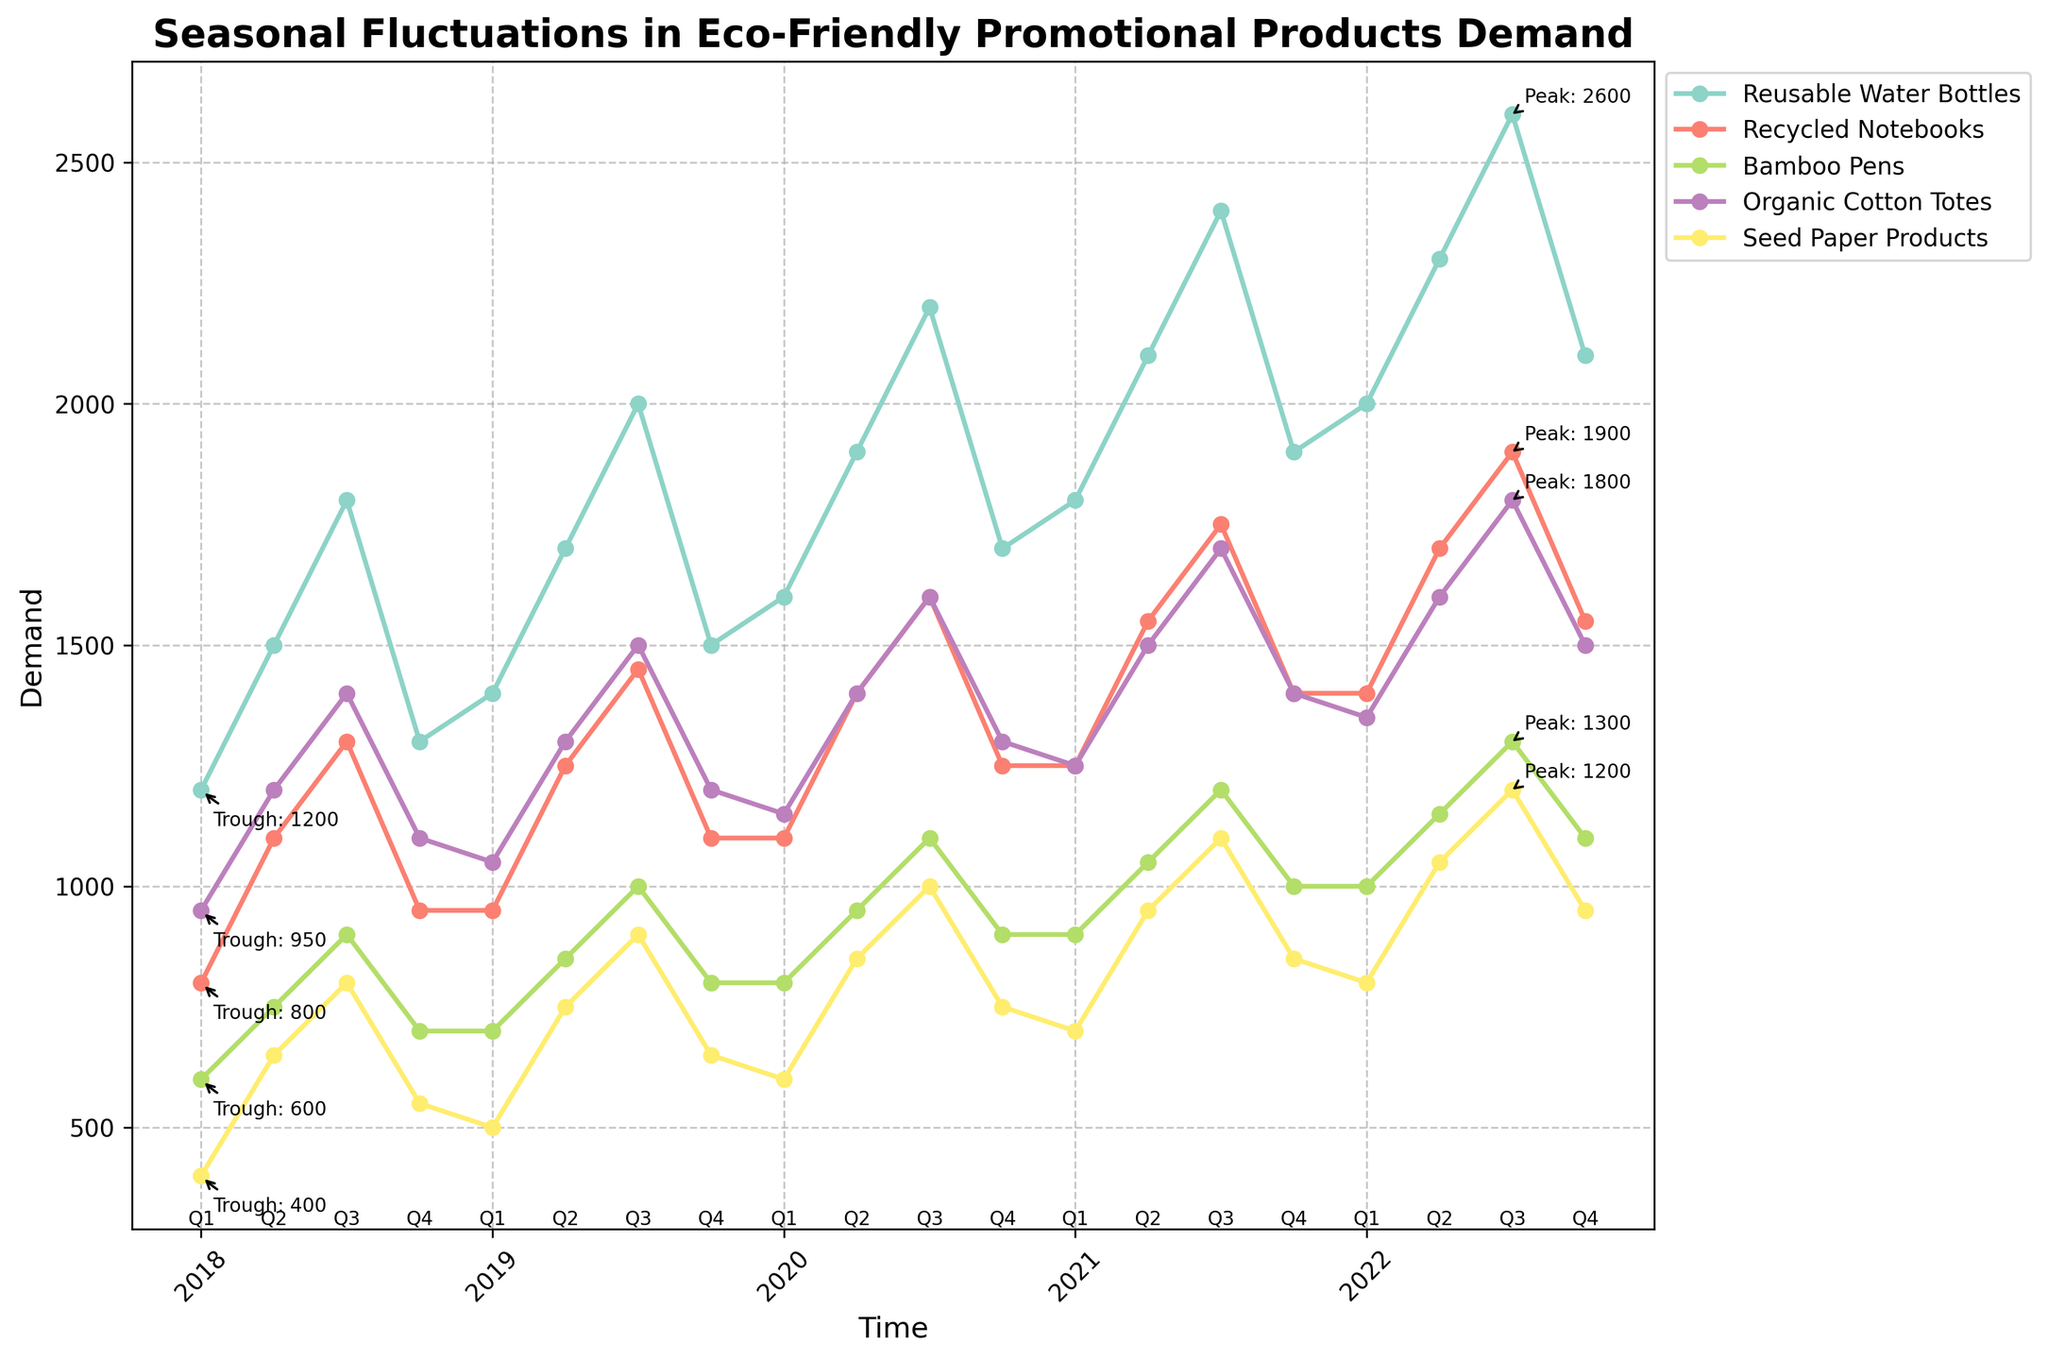What is the general trend for the demand of Reusable Water Bottles over the 5 years? Observing the line for Reusable Water Bottles, we see a generally increasing trend over the 5 years, with noticeable peaks during Q3 each year.
Answer: Increasing Which product saw the highest peak demand over the entire period? To find the highest peak, we need to look at the maximum value of each product line. Reusable Water Bottles had the highest value of 2600 in Q3 of 2022.
Answer: Reusable Water Bottles During which quarter was the demand for Recycled Notebooks at its lowest and what was the demand? By observing the line for Recycled Notebooks, the lowest point occurs in Q1 of 2018, with a demand of 800.
Answer: Q1 2018, 800 Compare the demand for Bamboo Pens in Q1 of 2019 and Q1 of 2021. Which one is higher and by how much? In Q1 of 2019, the demand for Bamboo Pens was 700. In Q1 of 2021, it was 900. The demand in Q1 of 2021 is higher by 200 units.
Answer: Q1 2021, by 200 units What is the average demand for Organic Cotton Totes in Q3 across all years? Summing the demand values for Organic Cotton Totes in Q3 for each year (1400, 1500, 1600, 1700, 1800) and dividing by the number of years, we get (1400 + 1500 + 1600 + 1700 + 1800) / 5 = 1600.
Answer: 1600 Which two products had the closest demand values in Q2 of 2022? In Q2 of 2022, the demand values are: Reusable Water Bottles: 2300, Recycled Notebooks: 1700, Bamboo Pens: 1150, Organic Cotton Totes: 1600, Seed Paper Products: 1050. The closest values are Organic Cotton Totes and Recycled Notebooks, differing by just 100 units.
Answer: Organic Cotton Totes and Recycled Notebooks What are the peak and trough demand values for Seed Paper Products, and during which quarters did they occur? The highest peak for Seed Paper Products is 1200 in Q3 of 2022 and the lowest trough is 400 in Q1 of 2018.
Answer: Peak: 1200 (Q3 2022), Trough: 400 (Q1 2018) How does the demand pattern for Bamboo Pens in 2021 compare to the previous year 2020? In 2021, the demand for Bamboo Pens is 900, 1050, 1200, 1000 per quarter. In 2020, the values were 800, 950, 1100, 900. Each quarter in 2021 shows higher demand compared to the corresponding quarter in 2020.
Answer: Higher demand in each quarter Which product showed the most consistent increase in demand year over year in Q4? Reusable Water Bottles in Q4 show values of 1300, 1500, 1700, 1900, 2100, consistently increasing each year.
Answer: Reusable Water Bottles What is the difference in peak demands between Organic Cotton Totes and Seed Paper Products? The peak demand for Organic Cotton Totes is 1800 in Q3 of 2022, while for Seed Paper Products, it is 1200 in Q3 of 2022. The difference is 1800 - 1200 = 600.
Answer: 600 